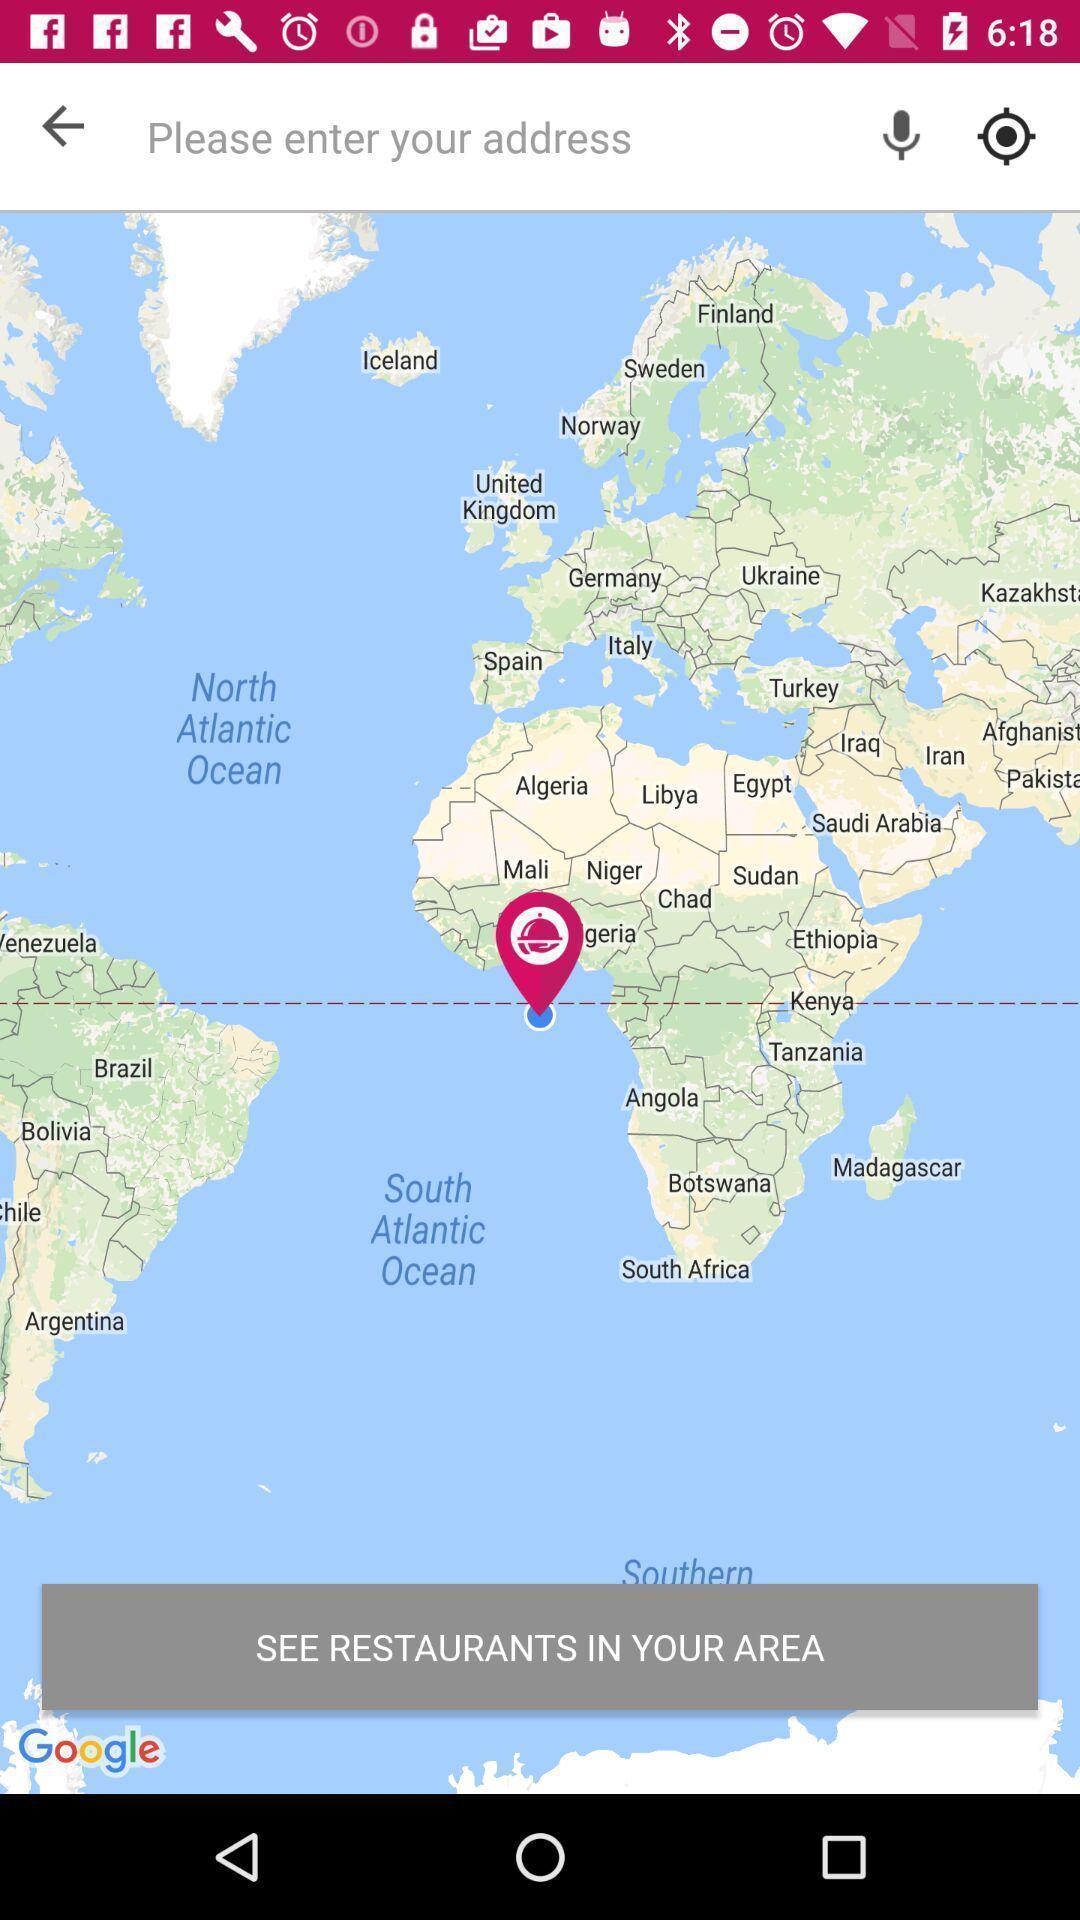Summarize the main components in this picture. Screen shows search address in a food app. 